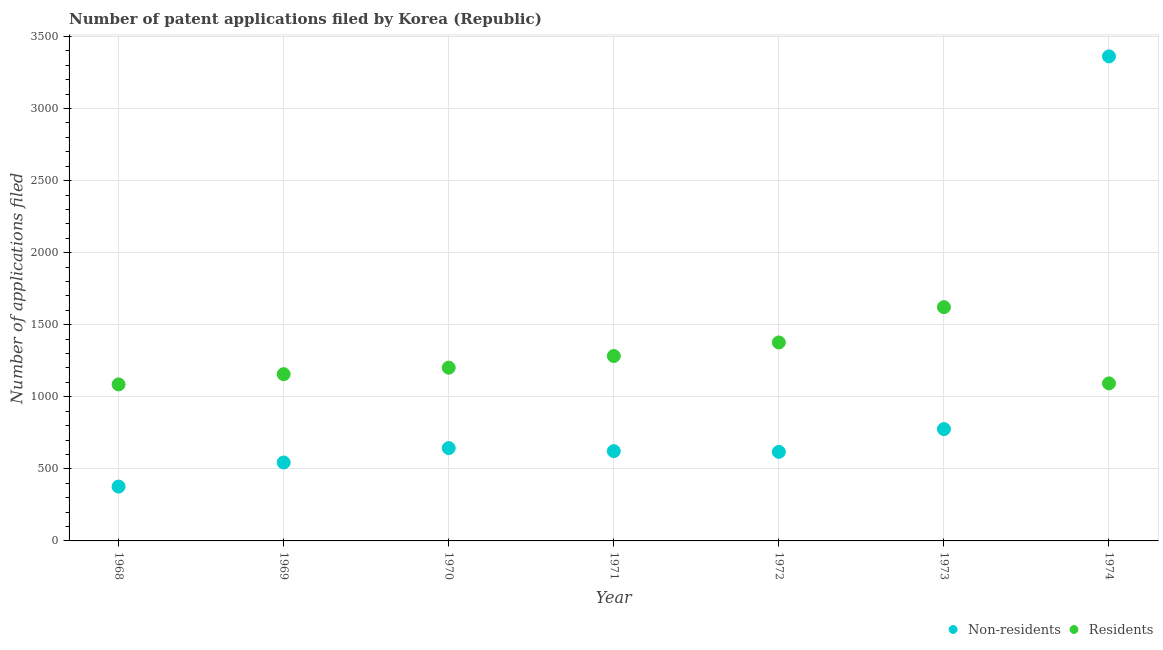How many different coloured dotlines are there?
Offer a terse response. 2. What is the number of patent applications by non residents in 1973?
Ensure brevity in your answer.  776. Across all years, what is the maximum number of patent applications by residents?
Your answer should be very brief. 1622. Across all years, what is the minimum number of patent applications by non residents?
Keep it short and to the point. 377. In which year was the number of patent applications by non residents maximum?
Keep it short and to the point. 1974. In which year was the number of patent applications by non residents minimum?
Ensure brevity in your answer.  1968. What is the total number of patent applications by non residents in the graph?
Your answer should be compact. 6944. What is the difference between the number of patent applications by non residents in 1972 and that in 1973?
Provide a short and direct response. -158. What is the difference between the number of patent applications by residents in 1972 and the number of patent applications by non residents in 1970?
Your answer should be compact. 733. What is the average number of patent applications by non residents per year?
Your answer should be very brief. 992. In the year 1969, what is the difference between the number of patent applications by residents and number of patent applications by non residents?
Keep it short and to the point. 613. In how many years, is the number of patent applications by residents greater than 2700?
Offer a terse response. 0. What is the ratio of the number of patent applications by non residents in 1970 to that in 1971?
Ensure brevity in your answer.  1.03. Is the number of patent applications by residents in 1968 less than that in 1970?
Make the answer very short. Yes. What is the difference between the highest and the second highest number of patent applications by non residents?
Provide a short and direct response. 2586. What is the difference between the highest and the lowest number of patent applications by residents?
Offer a very short reply. 536. Does the number of patent applications by residents monotonically increase over the years?
Your answer should be very brief. No. How many dotlines are there?
Keep it short and to the point. 2. What is the difference between two consecutive major ticks on the Y-axis?
Provide a short and direct response. 500. Are the values on the major ticks of Y-axis written in scientific E-notation?
Offer a terse response. No. Does the graph contain any zero values?
Keep it short and to the point. No. Does the graph contain grids?
Your answer should be very brief. Yes. Where does the legend appear in the graph?
Provide a short and direct response. Bottom right. How many legend labels are there?
Provide a short and direct response. 2. How are the legend labels stacked?
Your answer should be very brief. Horizontal. What is the title of the graph?
Your answer should be compact. Number of patent applications filed by Korea (Republic). What is the label or title of the Y-axis?
Your answer should be compact. Number of applications filed. What is the Number of applications filed in Non-residents in 1968?
Offer a very short reply. 377. What is the Number of applications filed in Residents in 1968?
Your response must be concise. 1086. What is the Number of applications filed of Non-residents in 1969?
Provide a succinct answer. 544. What is the Number of applications filed of Residents in 1969?
Your response must be concise. 1157. What is the Number of applications filed in Non-residents in 1970?
Offer a terse response. 644. What is the Number of applications filed in Residents in 1970?
Give a very brief answer. 1202. What is the Number of applications filed of Non-residents in 1971?
Your answer should be compact. 623. What is the Number of applications filed in Residents in 1971?
Your answer should be compact. 1283. What is the Number of applications filed in Non-residents in 1972?
Provide a succinct answer. 618. What is the Number of applications filed of Residents in 1972?
Make the answer very short. 1377. What is the Number of applications filed in Non-residents in 1973?
Offer a very short reply. 776. What is the Number of applications filed of Residents in 1973?
Ensure brevity in your answer.  1622. What is the Number of applications filed of Non-residents in 1974?
Your answer should be compact. 3362. What is the Number of applications filed of Residents in 1974?
Your response must be concise. 1093. Across all years, what is the maximum Number of applications filed of Non-residents?
Your answer should be very brief. 3362. Across all years, what is the maximum Number of applications filed of Residents?
Your answer should be very brief. 1622. Across all years, what is the minimum Number of applications filed of Non-residents?
Keep it short and to the point. 377. Across all years, what is the minimum Number of applications filed in Residents?
Keep it short and to the point. 1086. What is the total Number of applications filed in Non-residents in the graph?
Offer a very short reply. 6944. What is the total Number of applications filed of Residents in the graph?
Your answer should be very brief. 8820. What is the difference between the Number of applications filed in Non-residents in 1968 and that in 1969?
Provide a short and direct response. -167. What is the difference between the Number of applications filed in Residents in 1968 and that in 1969?
Ensure brevity in your answer.  -71. What is the difference between the Number of applications filed in Non-residents in 1968 and that in 1970?
Make the answer very short. -267. What is the difference between the Number of applications filed of Residents in 1968 and that in 1970?
Provide a succinct answer. -116. What is the difference between the Number of applications filed of Non-residents in 1968 and that in 1971?
Your response must be concise. -246. What is the difference between the Number of applications filed in Residents in 1968 and that in 1971?
Ensure brevity in your answer.  -197. What is the difference between the Number of applications filed of Non-residents in 1968 and that in 1972?
Your answer should be very brief. -241. What is the difference between the Number of applications filed of Residents in 1968 and that in 1972?
Give a very brief answer. -291. What is the difference between the Number of applications filed of Non-residents in 1968 and that in 1973?
Ensure brevity in your answer.  -399. What is the difference between the Number of applications filed of Residents in 1968 and that in 1973?
Your answer should be compact. -536. What is the difference between the Number of applications filed in Non-residents in 1968 and that in 1974?
Ensure brevity in your answer.  -2985. What is the difference between the Number of applications filed in Non-residents in 1969 and that in 1970?
Provide a succinct answer. -100. What is the difference between the Number of applications filed of Residents in 1969 and that in 1970?
Give a very brief answer. -45. What is the difference between the Number of applications filed of Non-residents in 1969 and that in 1971?
Offer a terse response. -79. What is the difference between the Number of applications filed of Residents in 1969 and that in 1971?
Make the answer very short. -126. What is the difference between the Number of applications filed of Non-residents in 1969 and that in 1972?
Give a very brief answer. -74. What is the difference between the Number of applications filed in Residents in 1969 and that in 1972?
Your answer should be very brief. -220. What is the difference between the Number of applications filed of Non-residents in 1969 and that in 1973?
Offer a very short reply. -232. What is the difference between the Number of applications filed of Residents in 1969 and that in 1973?
Provide a short and direct response. -465. What is the difference between the Number of applications filed in Non-residents in 1969 and that in 1974?
Your answer should be compact. -2818. What is the difference between the Number of applications filed of Residents in 1970 and that in 1971?
Your response must be concise. -81. What is the difference between the Number of applications filed of Non-residents in 1970 and that in 1972?
Make the answer very short. 26. What is the difference between the Number of applications filed in Residents in 1970 and that in 1972?
Offer a very short reply. -175. What is the difference between the Number of applications filed in Non-residents in 1970 and that in 1973?
Offer a terse response. -132. What is the difference between the Number of applications filed in Residents in 1970 and that in 1973?
Ensure brevity in your answer.  -420. What is the difference between the Number of applications filed in Non-residents in 1970 and that in 1974?
Provide a short and direct response. -2718. What is the difference between the Number of applications filed of Residents in 1970 and that in 1974?
Your answer should be compact. 109. What is the difference between the Number of applications filed in Non-residents in 1971 and that in 1972?
Offer a very short reply. 5. What is the difference between the Number of applications filed of Residents in 1971 and that in 1972?
Make the answer very short. -94. What is the difference between the Number of applications filed of Non-residents in 1971 and that in 1973?
Keep it short and to the point. -153. What is the difference between the Number of applications filed of Residents in 1971 and that in 1973?
Provide a succinct answer. -339. What is the difference between the Number of applications filed in Non-residents in 1971 and that in 1974?
Your answer should be very brief. -2739. What is the difference between the Number of applications filed of Residents in 1971 and that in 1974?
Your response must be concise. 190. What is the difference between the Number of applications filed in Non-residents in 1972 and that in 1973?
Offer a very short reply. -158. What is the difference between the Number of applications filed in Residents in 1972 and that in 1973?
Ensure brevity in your answer.  -245. What is the difference between the Number of applications filed of Non-residents in 1972 and that in 1974?
Give a very brief answer. -2744. What is the difference between the Number of applications filed in Residents in 1972 and that in 1974?
Your answer should be compact. 284. What is the difference between the Number of applications filed in Non-residents in 1973 and that in 1974?
Offer a very short reply. -2586. What is the difference between the Number of applications filed in Residents in 1973 and that in 1974?
Provide a short and direct response. 529. What is the difference between the Number of applications filed in Non-residents in 1968 and the Number of applications filed in Residents in 1969?
Offer a very short reply. -780. What is the difference between the Number of applications filed in Non-residents in 1968 and the Number of applications filed in Residents in 1970?
Give a very brief answer. -825. What is the difference between the Number of applications filed in Non-residents in 1968 and the Number of applications filed in Residents in 1971?
Make the answer very short. -906. What is the difference between the Number of applications filed in Non-residents in 1968 and the Number of applications filed in Residents in 1972?
Your response must be concise. -1000. What is the difference between the Number of applications filed in Non-residents in 1968 and the Number of applications filed in Residents in 1973?
Provide a succinct answer. -1245. What is the difference between the Number of applications filed in Non-residents in 1968 and the Number of applications filed in Residents in 1974?
Your response must be concise. -716. What is the difference between the Number of applications filed of Non-residents in 1969 and the Number of applications filed of Residents in 1970?
Provide a succinct answer. -658. What is the difference between the Number of applications filed in Non-residents in 1969 and the Number of applications filed in Residents in 1971?
Keep it short and to the point. -739. What is the difference between the Number of applications filed in Non-residents in 1969 and the Number of applications filed in Residents in 1972?
Provide a succinct answer. -833. What is the difference between the Number of applications filed of Non-residents in 1969 and the Number of applications filed of Residents in 1973?
Ensure brevity in your answer.  -1078. What is the difference between the Number of applications filed of Non-residents in 1969 and the Number of applications filed of Residents in 1974?
Provide a succinct answer. -549. What is the difference between the Number of applications filed in Non-residents in 1970 and the Number of applications filed in Residents in 1971?
Your answer should be very brief. -639. What is the difference between the Number of applications filed in Non-residents in 1970 and the Number of applications filed in Residents in 1972?
Offer a very short reply. -733. What is the difference between the Number of applications filed of Non-residents in 1970 and the Number of applications filed of Residents in 1973?
Provide a succinct answer. -978. What is the difference between the Number of applications filed of Non-residents in 1970 and the Number of applications filed of Residents in 1974?
Your response must be concise. -449. What is the difference between the Number of applications filed in Non-residents in 1971 and the Number of applications filed in Residents in 1972?
Give a very brief answer. -754. What is the difference between the Number of applications filed of Non-residents in 1971 and the Number of applications filed of Residents in 1973?
Make the answer very short. -999. What is the difference between the Number of applications filed of Non-residents in 1971 and the Number of applications filed of Residents in 1974?
Offer a terse response. -470. What is the difference between the Number of applications filed of Non-residents in 1972 and the Number of applications filed of Residents in 1973?
Keep it short and to the point. -1004. What is the difference between the Number of applications filed in Non-residents in 1972 and the Number of applications filed in Residents in 1974?
Provide a succinct answer. -475. What is the difference between the Number of applications filed of Non-residents in 1973 and the Number of applications filed of Residents in 1974?
Provide a succinct answer. -317. What is the average Number of applications filed in Non-residents per year?
Ensure brevity in your answer.  992. What is the average Number of applications filed in Residents per year?
Keep it short and to the point. 1260. In the year 1968, what is the difference between the Number of applications filed of Non-residents and Number of applications filed of Residents?
Your response must be concise. -709. In the year 1969, what is the difference between the Number of applications filed of Non-residents and Number of applications filed of Residents?
Keep it short and to the point. -613. In the year 1970, what is the difference between the Number of applications filed of Non-residents and Number of applications filed of Residents?
Provide a succinct answer. -558. In the year 1971, what is the difference between the Number of applications filed in Non-residents and Number of applications filed in Residents?
Make the answer very short. -660. In the year 1972, what is the difference between the Number of applications filed of Non-residents and Number of applications filed of Residents?
Make the answer very short. -759. In the year 1973, what is the difference between the Number of applications filed of Non-residents and Number of applications filed of Residents?
Provide a succinct answer. -846. In the year 1974, what is the difference between the Number of applications filed in Non-residents and Number of applications filed in Residents?
Your answer should be very brief. 2269. What is the ratio of the Number of applications filed in Non-residents in 1968 to that in 1969?
Keep it short and to the point. 0.69. What is the ratio of the Number of applications filed of Residents in 1968 to that in 1969?
Provide a succinct answer. 0.94. What is the ratio of the Number of applications filed in Non-residents in 1968 to that in 1970?
Offer a very short reply. 0.59. What is the ratio of the Number of applications filed in Residents in 1968 to that in 1970?
Your response must be concise. 0.9. What is the ratio of the Number of applications filed in Non-residents in 1968 to that in 1971?
Keep it short and to the point. 0.61. What is the ratio of the Number of applications filed of Residents in 1968 to that in 1971?
Offer a terse response. 0.85. What is the ratio of the Number of applications filed in Non-residents in 1968 to that in 1972?
Your response must be concise. 0.61. What is the ratio of the Number of applications filed in Residents in 1968 to that in 1972?
Make the answer very short. 0.79. What is the ratio of the Number of applications filed in Non-residents in 1968 to that in 1973?
Offer a terse response. 0.49. What is the ratio of the Number of applications filed of Residents in 1968 to that in 1973?
Offer a very short reply. 0.67. What is the ratio of the Number of applications filed of Non-residents in 1968 to that in 1974?
Your answer should be compact. 0.11. What is the ratio of the Number of applications filed in Residents in 1968 to that in 1974?
Your response must be concise. 0.99. What is the ratio of the Number of applications filed of Non-residents in 1969 to that in 1970?
Offer a terse response. 0.84. What is the ratio of the Number of applications filed in Residents in 1969 to that in 1970?
Give a very brief answer. 0.96. What is the ratio of the Number of applications filed of Non-residents in 1969 to that in 1971?
Offer a very short reply. 0.87. What is the ratio of the Number of applications filed in Residents in 1969 to that in 1971?
Ensure brevity in your answer.  0.9. What is the ratio of the Number of applications filed in Non-residents in 1969 to that in 1972?
Offer a very short reply. 0.88. What is the ratio of the Number of applications filed in Residents in 1969 to that in 1972?
Offer a very short reply. 0.84. What is the ratio of the Number of applications filed of Non-residents in 1969 to that in 1973?
Provide a short and direct response. 0.7. What is the ratio of the Number of applications filed in Residents in 1969 to that in 1973?
Keep it short and to the point. 0.71. What is the ratio of the Number of applications filed of Non-residents in 1969 to that in 1974?
Make the answer very short. 0.16. What is the ratio of the Number of applications filed of Residents in 1969 to that in 1974?
Your response must be concise. 1.06. What is the ratio of the Number of applications filed in Non-residents in 1970 to that in 1971?
Your answer should be compact. 1.03. What is the ratio of the Number of applications filed of Residents in 1970 to that in 1971?
Make the answer very short. 0.94. What is the ratio of the Number of applications filed of Non-residents in 1970 to that in 1972?
Your answer should be compact. 1.04. What is the ratio of the Number of applications filed in Residents in 1970 to that in 1972?
Provide a succinct answer. 0.87. What is the ratio of the Number of applications filed in Non-residents in 1970 to that in 1973?
Offer a terse response. 0.83. What is the ratio of the Number of applications filed in Residents in 1970 to that in 1973?
Your answer should be very brief. 0.74. What is the ratio of the Number of applications filed of Non-residents in 1970 to that in 1974?
Your answer should be compact. 0.19. What is the ratio of the Number of applications filed in Residents in 1970 to that in 1974?
Ensure brevity in your answer.  1.1. What is the ratio of the Number of applications filed of Residents in 1971 to that in 1972?
Offer a very short reply. 0.93. What is the ratio of the Number of applications filed in Non-residents in 1971 to that in 1973?
Offer a terse response. 0.8. What is the ratio of the Number of applications filed of Residents in 1971 to that in 1973?
Provide a short and direct response. 0.79. What is the ratio of the Number of applications filed in Non-residents in 1971 to that in 1974?
Provide a short and direct response. 0.19. What is the ratio of the Number of applications filed of Residents in 1971 to that in 1974?
Keep it short and to the point. 1.17. What is the ratio of the Number of applications filed of Non-residents in 1972 to that in 1973?
Provide a succinct answer. 0.8. What is the ratio of the Number of applications filed in Residents in 1972 to that in 1973?
Offer a terse response. 0.85. What is the ratio of the Number of applications filed in Non-residents in 1972 to that in 1974?
Give a very brief answer. 0.18. What is the ratio of the Number of applications filed of Residents in 1972 to that in 1974?
Give a very brief answer. 1.26. What is the ratio of the Number of applications filed of Non-residents in 1973 to that in 1974?
Provide a short and direct response. 0.23. What is the ratio of the Number of applications filed of Residents in 1973 to that in 1974?
Ensure brevity in your answer.  1.48. What is the difference between the highest and the second highest Number of applications filed in Non-residents?
Offer a terse response. 2586. What is the difference between the highest and the second highest Number of applications filed in Residents?
Ensure brevity in your answer.  245. What is the difference between the highest and the lowest Number of applications filed in Non-residents?
Your answer should be very brief. 2985. What is the difference between the highest and the lowest Number of applications filed in Residents?
Ensure brevity in your answer.  536. 